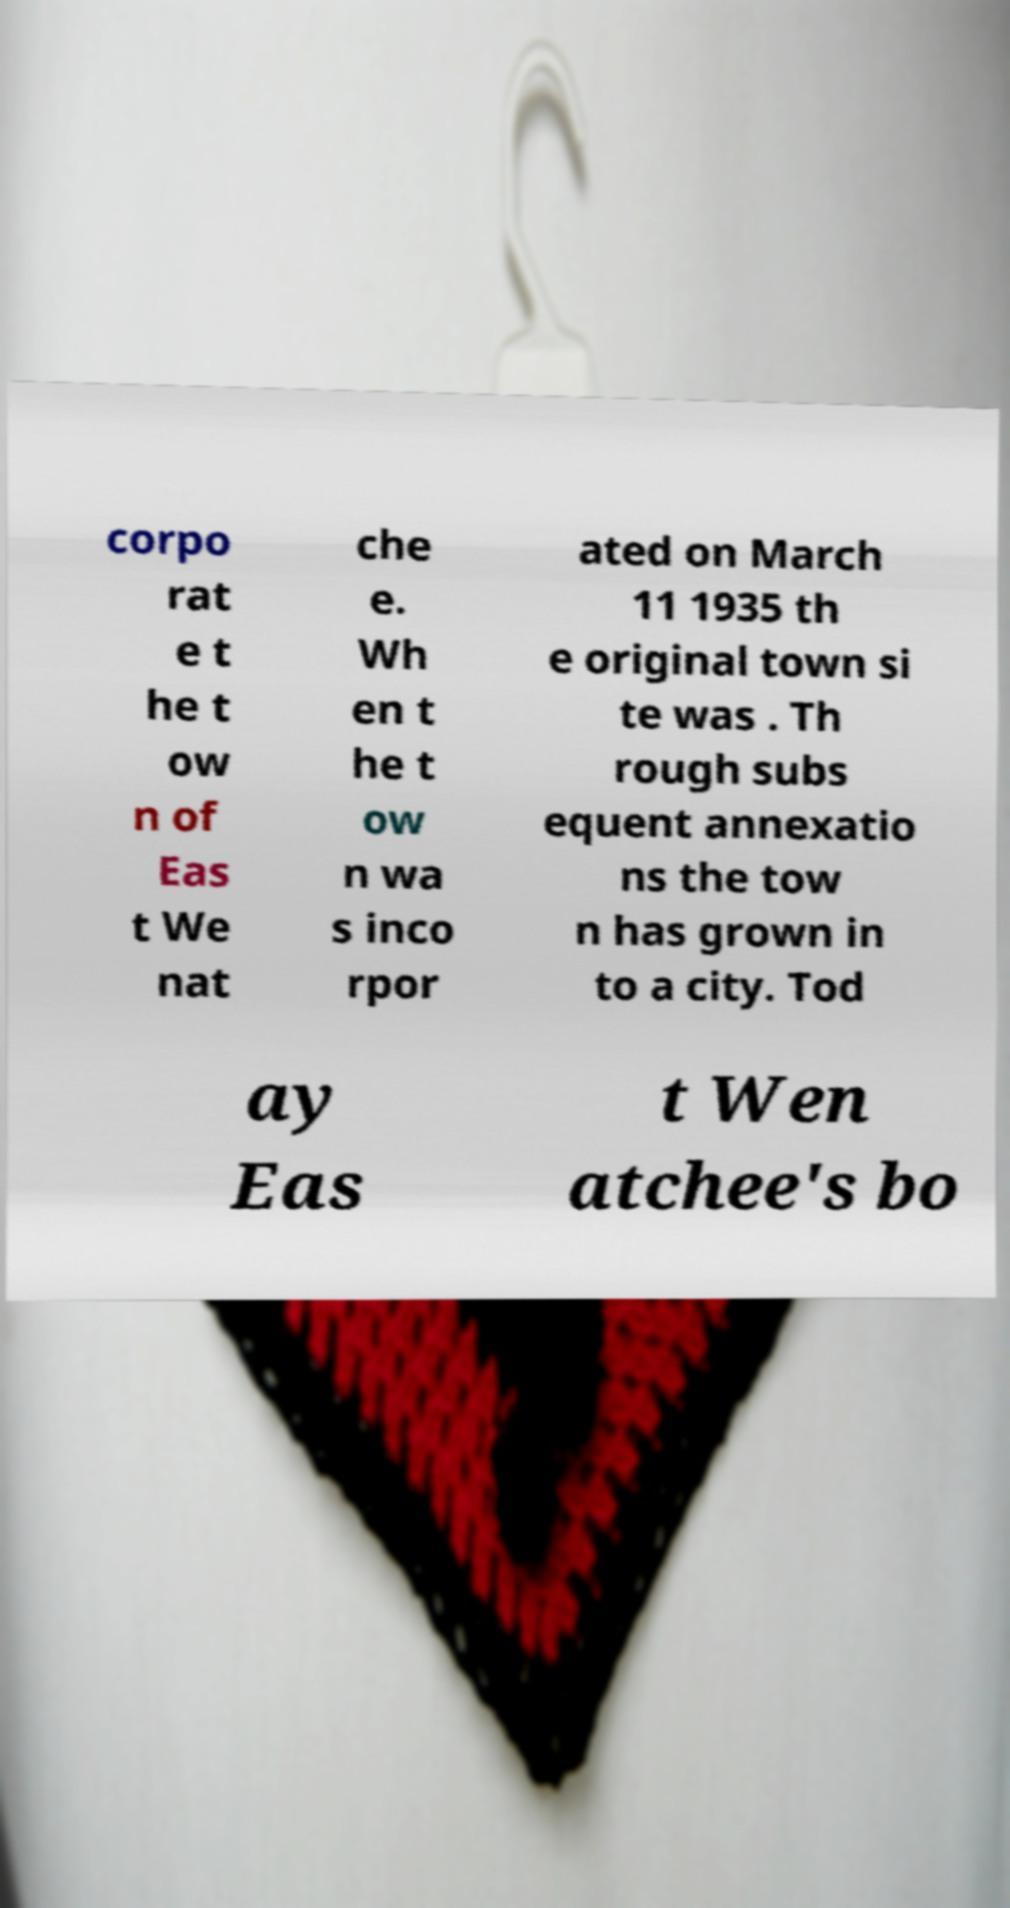Can you read and provide the text displayed in the image?This photo seems to have some interesting text. Can you extract and type it out for me? corpo rat e t he t ow n of Eas t We nat che e. Wh en t he t ow n wa s inco rpor ated on March 11 1935 th e original town si te was . Th rough subs equent annexatio ns the tow n has grown in to a city. Tod ay Eas t Wen atchee's bo 